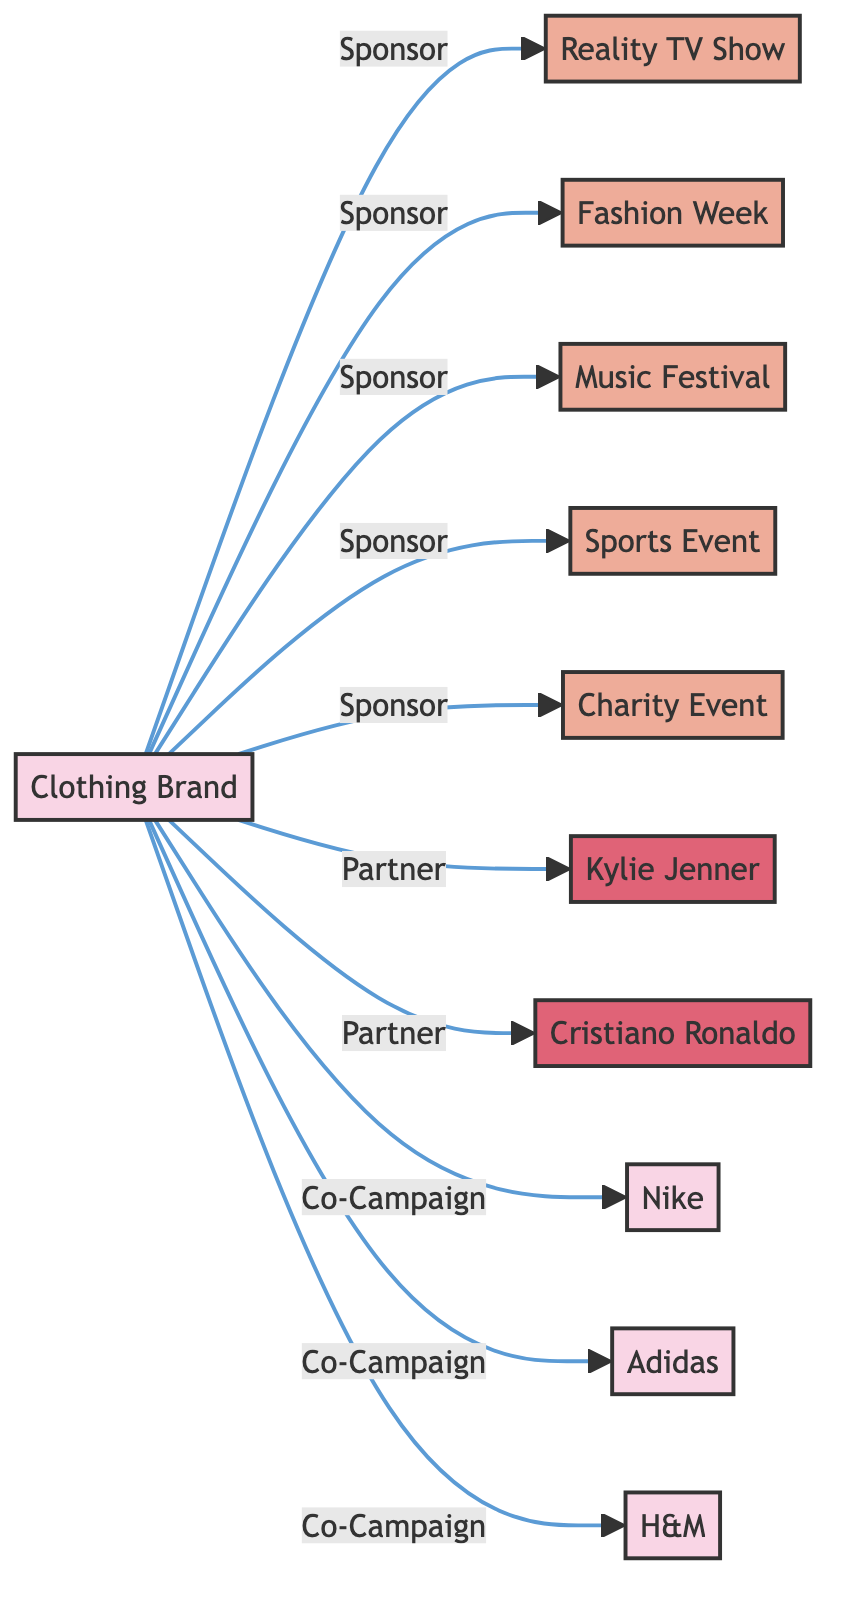What is the total number of nodes in the diagram? The nodes in the diagram include the Clothing Brand, five events, two influencers, and three partner brands. Therefore, adding them together, the total is 11 nodes.
Answer: 11 Which event is sponsored by the Clothing Brand that focuses on entertainment? The Clothing Brand sponsors the Reality TV Show, which is focused on entertainment, as shown by the connection labeled "Sponsor."
Answer: Reality TV Show How many influencers are partners with the Clothing Brand? The Clothing Brand has partnerships with two influencers, namely Kylie Jenner and Cristiano Ronaldo, indicated by the connections labeled "Partner."
Answer: 2 What type of relationships exist between the Clothing Brand and Partner Brand - H&M? The relationship between the Clothing Brand and Partner Brand - H&M is labeled as "Co-Campaign," indicating a collaborative marketing effort.
Answer: Co-Campaign Which event does the Clothing Brand sponsor that is related to social causes? The Clothing Brand sponsors the Charity Event, which is directly connected as a sponsored event labeled "Sponsor."
Answer: Charity Event How many events in total does the Clothing Brand sponsor? By counting the connections labeled "Sponsor," the Clothing Brand sponsors five events: Reality TV Show, Fashion Week, Music Festival, Sports Event, and Charity Event.
Answer: 5 What type of network diagram is represented by this data? The diagram represents a network of sponsorships and partnerships among a clothing brand, influencers, partner brands, and various events, indicating different types of relationships among them.
Answer: Network Diagram Which brand collaborates with the Clothing Brand for campaigns alongside Nike and Adidas? The Clothing Brand collaborates with three partner brands for co-campaigns: Nike, Adidas, and H&M, all indicated with the connection "Co-Campaign."
Answer: H&M What is the relationship between the Clothing Brand and Music Festival? The relationship between the Clothing Brand and Music Festival is labeled "Sponsor," showing that the Clothing Brand is a sponsor for this event.
Answer: Sponsor 